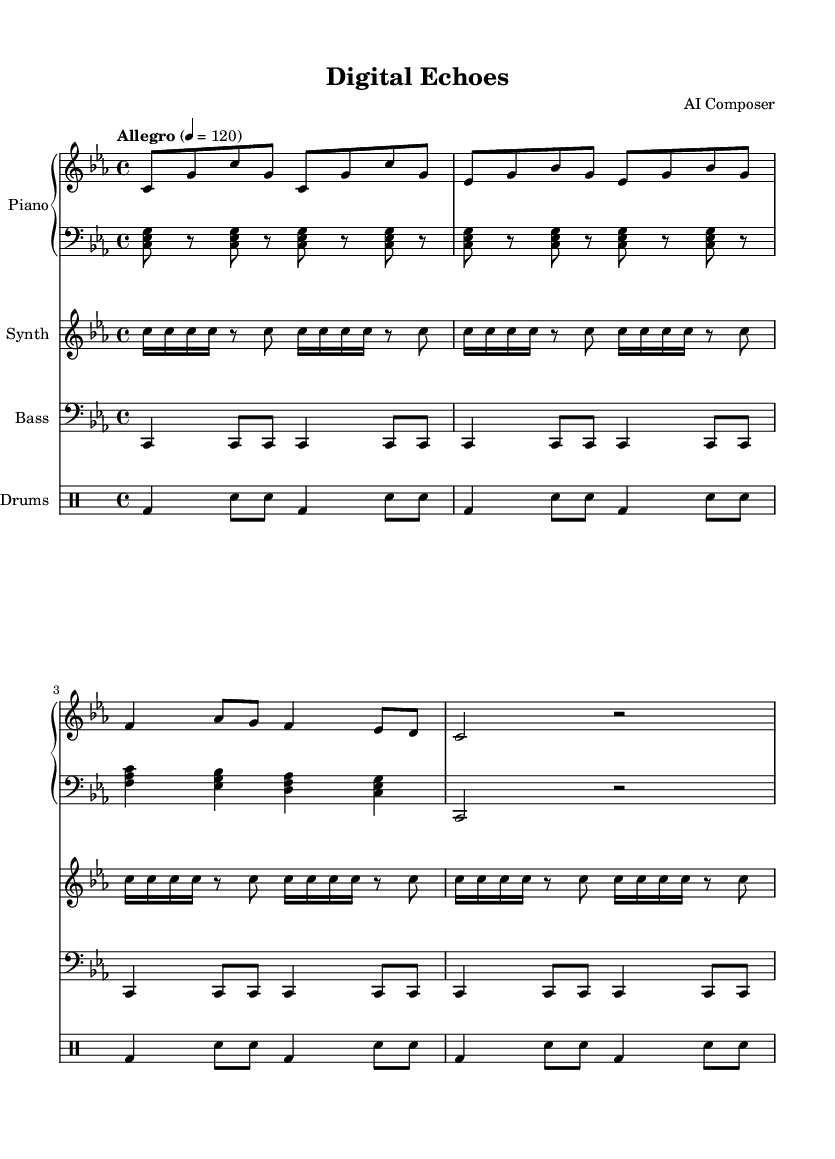What is the key signature of this music? The key signature is indicated at the beginning of the staff with a flat symbol on the B line, which signifies C minor (three flats: B♭, E♭, A♭).
Answer: C minor What is the time signature of this piece? The time signature is displayed as a fraction at the beginning of the staff, indicating four beats in a measure and the quarter note gets one beat.
Answer: 4/4 What is the tempo marking of this piece? The tempo marking is stated above the staff as "Allegro" followed by a metronome marking of 120, indicating a fast pace.
Answer: Allegro 4 = 120 How many measures are in the right hand part? To find the number of measures, count the measure bars (vertical lines) in the right hand part, which includes one complete grouping of music. In this case, there are 8 measures clearly identifiable.
Answer: 8 What instrument is indicated as having a synthesizer part? The instrument with the synthesizer part is shown on a separate staff labeled "Synth," indicating that this part is designed for a synthesizer.
Answer: Synth What type of percussion is used in the drum part? The drum part is labeled "Drums" and follows a snare-bass pattern typically found in contemporary music, showing it includes staves for pitched drums, specifically bass drum (bd) and snare (sn).
Answer: Pitched drums What note value predominantly appears in the left hand part? By observing the left hand part, the majority of notes presented are eighth notes, as indicated by their notation, signaling a repetitive rhythmic pattern.
Answer: Eighth notes 